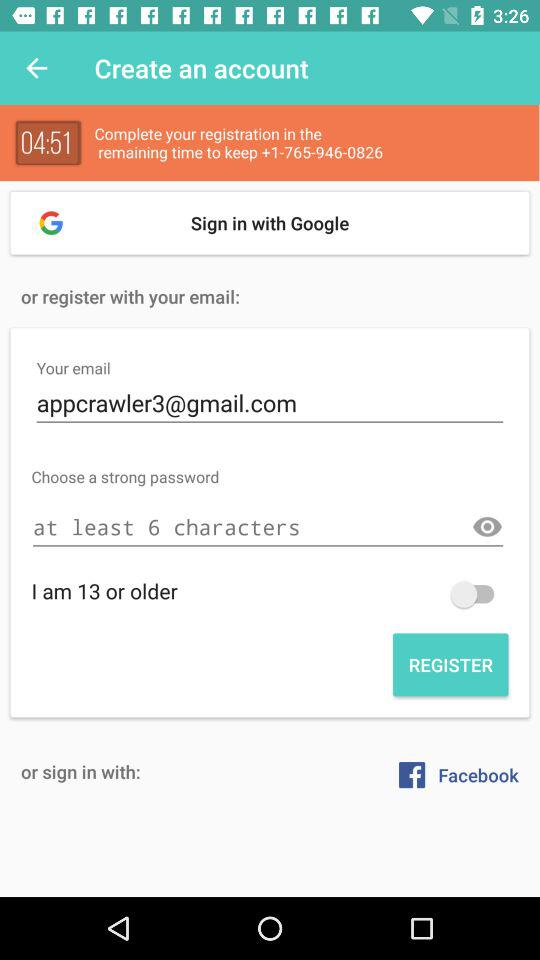What is the email address? The email address is appcrawler3@gmail.com. 